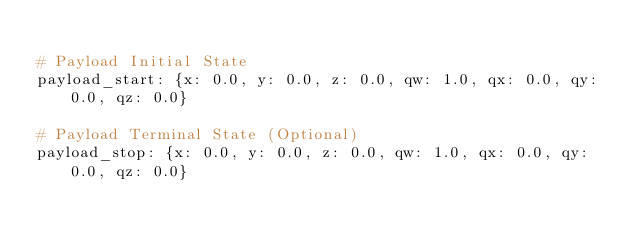<code> <loc_0><loc_0><loc_500><loc_500><_YAML_>
# Payload Initial State
payload_start: {x: 0.0, y: 0.0, z: 0.0, qw: 1.0, qx: 0.0, qy: 0.0, qz: 0.0}

# Payload Terminal State (Optional)
payload_stop: {x: 0.0, y: 0.0, z: 0.0, qw: 1.0, qx: 0.0, qy: 0.0, qz: 0.0}</code> 